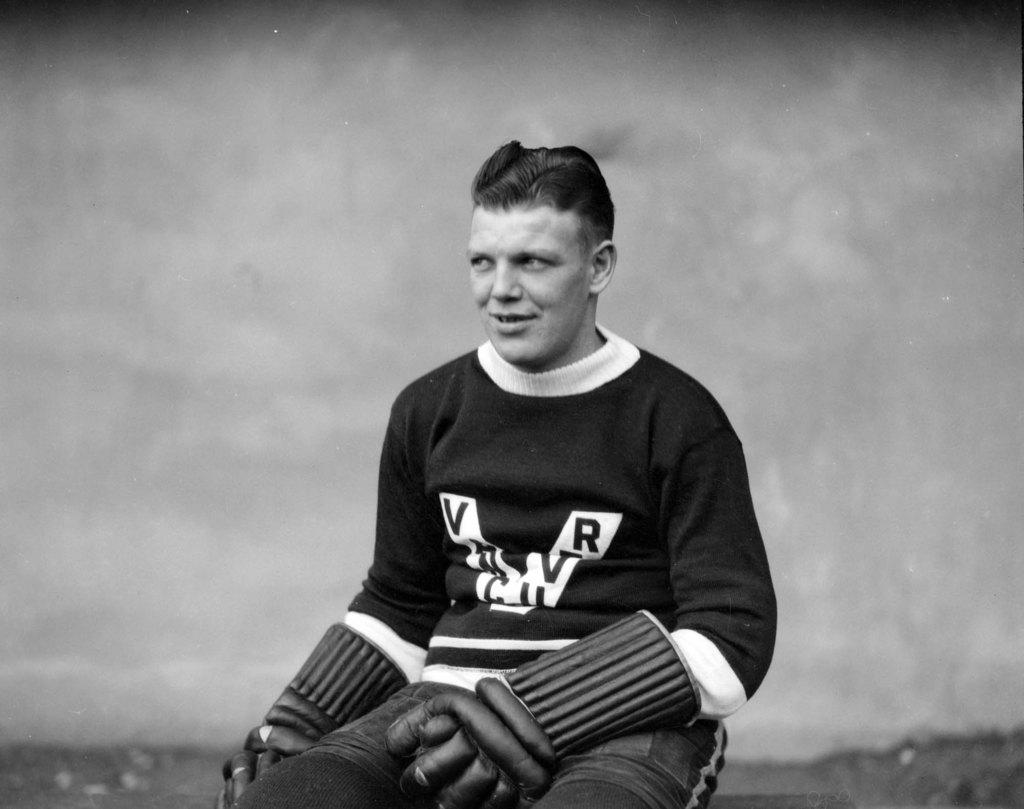<image>
Relay a brief, clear account of the picture shown. Very old photograph of someone wearing sweater that has an obstructed name on it that starts with V and ends with R. 